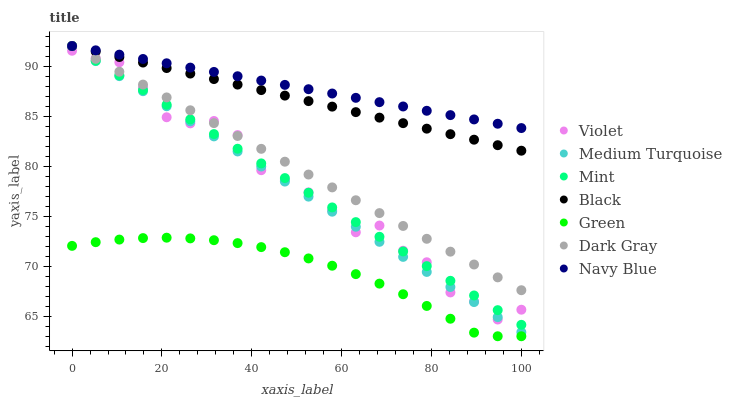Does Green have the minimum area under the curve?
Answer yes or no. Yes. Does Navy Blue have the maximum area under the curve?
Answer yes or no. Yes. Does Dark Gray have the minimum area under the curve?
Answer yes or no. No. Does Dark Gray have the maximum area under the curve?
Answer yes or no. No. Is Navy Blue the smoothest?
Answer yes or no. Yes. Is Violet the roughest?
Answer yes or no. Yes. Is Dark Gray the smoothest?
Answer yes or no. No. Is Dark Gray the roughest?
Answer yes or no. No. Does Green have the lowest value?
Answer yes or no. Yes. Does Dark Gray have the lowest value?
Answer yes or no. No. Does Mint have the highest value?
Answer yes or no. Yes. Does Violet have the highest value?
Answer yes or no. No. Is Green less than Mint?
Answer yes or no. Yes. Is Navy Blue greater than Violet?
Answer yes or no. Yes. Does Dark Gray intersect Navy Blue?
Answer yes or no. Yes. Is Dark Gray less than Navy Blue?
Answer yes or no. No. Is Dark Gray greater than Navy Blue?
Answer yes or no. No. Does Green intersect Mint?
Answer yes or no. No. 